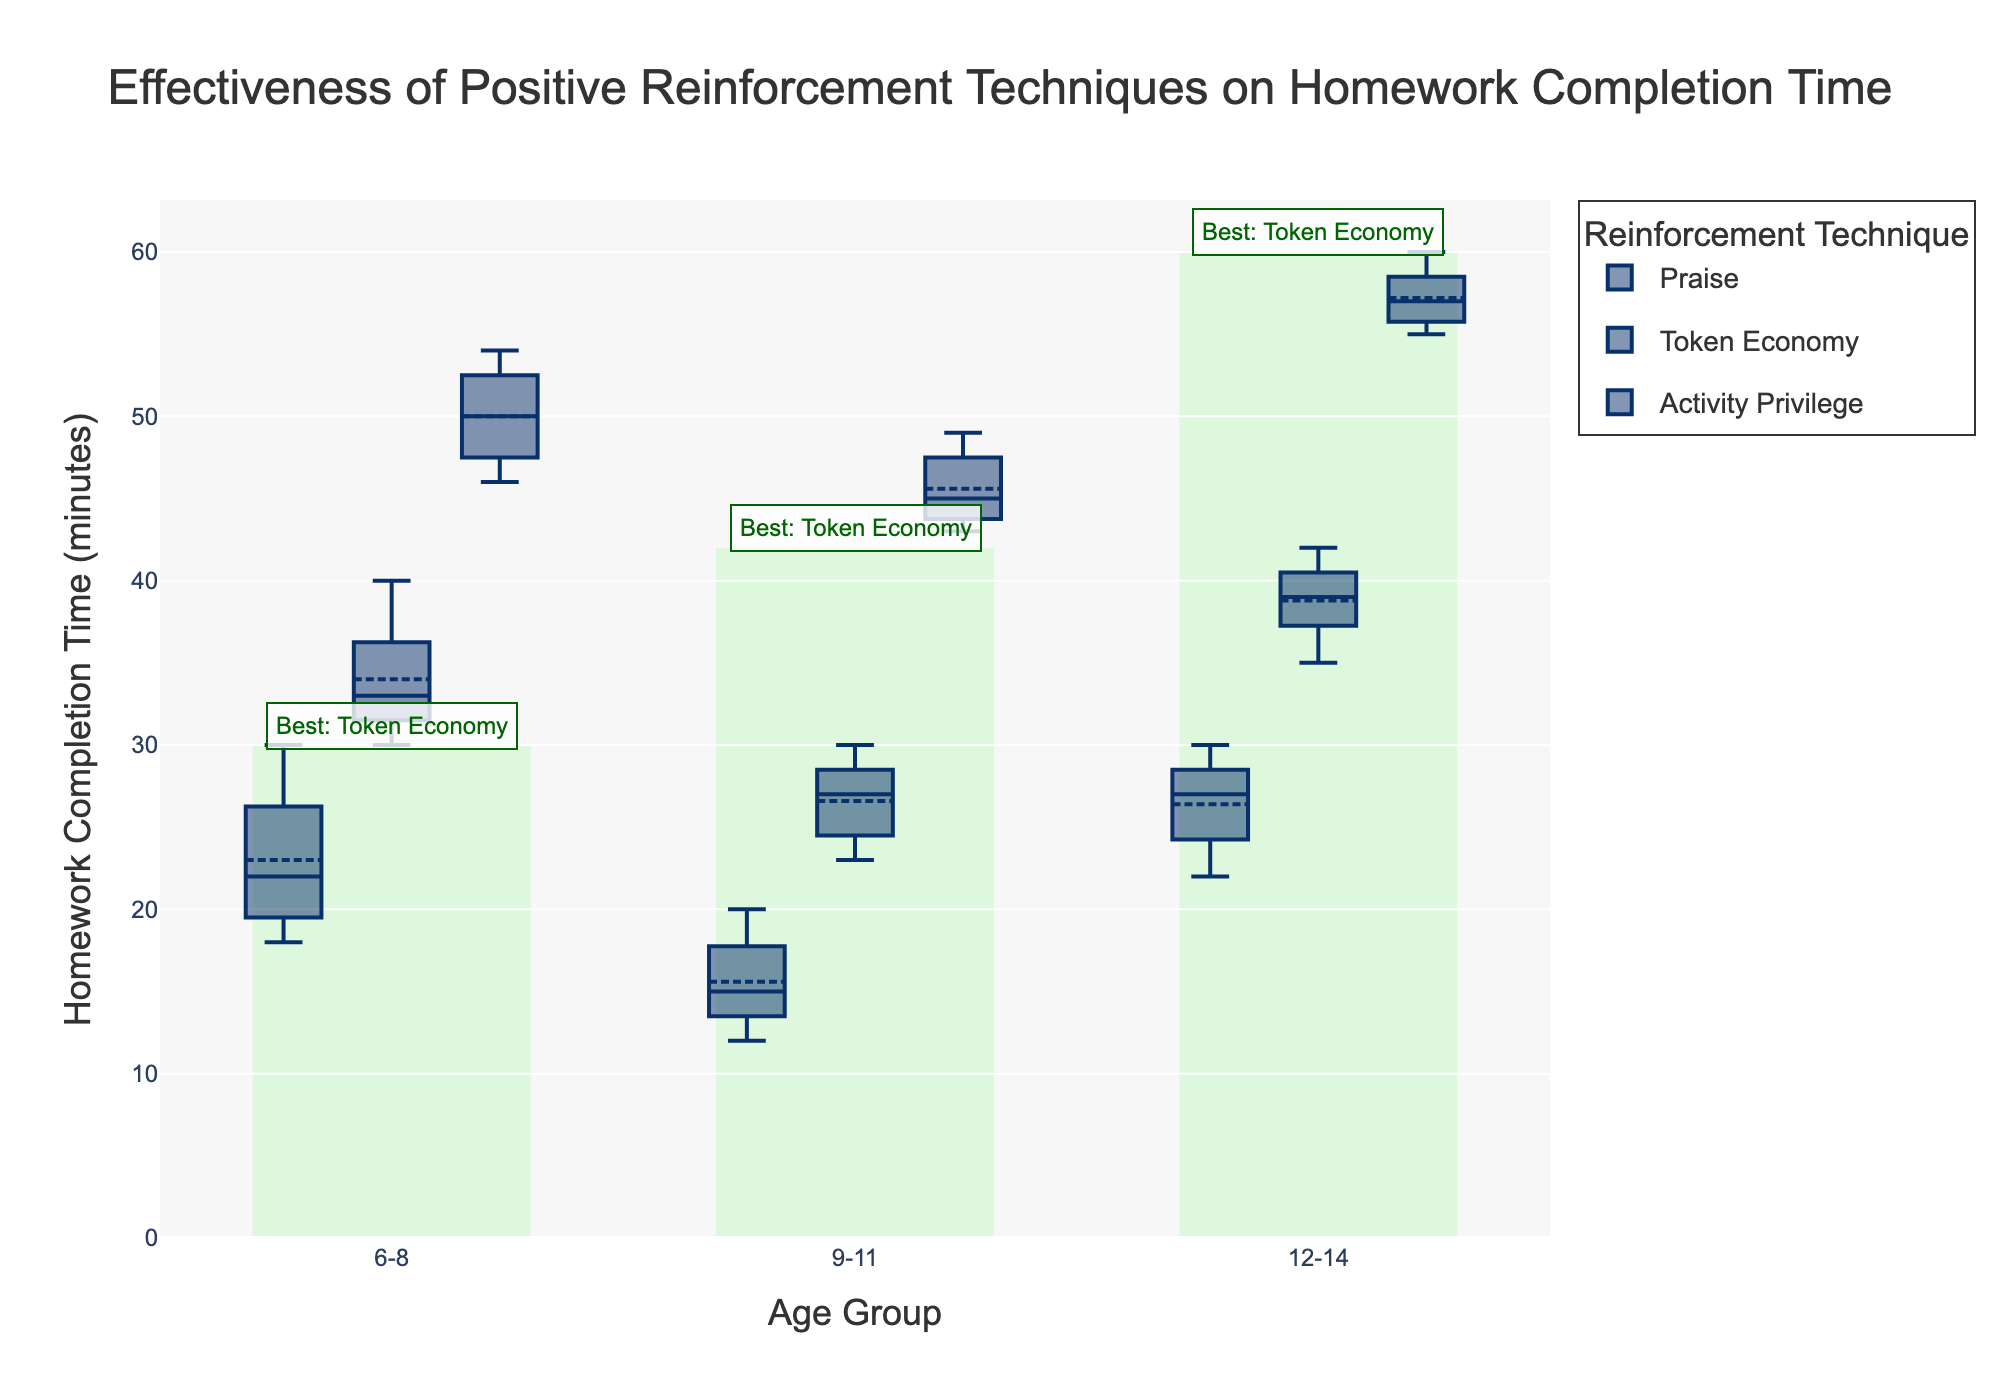What is the title of the plot? The title of the plot is found at the top center of the figure and is used to describe the overall content of the plot.
Answer: Effectiveness of Positive Reinforcement Techniques on Homework Completion Time Which age group takes the longest time to complete homework according to the plot? By looking at the y-axis which shows homework completion time and comparing across age groups, the group with the highest median value indicates the longest completion time.
Answer: 12-14 What is the shortest average homework completion time for the 6-8 age group? Identify the mean value for each reinforcement technique within the 6-8 age group and find the one with the lowest mean.
Answer: Token Economy Which reinforcement technique is indicated as the most effective for the 9-11 age group? This is highlighted in the figure with a specific annotation for the age group 9-11. Look for the annotation text indicating "Best" on the plot.
Answer: Token Economy How do the completion times compare between Praise and Token Economy for the 12-14 age group? Compare the medians of the box plots for the two techniques within the 12-14 age group. The one with a higher median indicates longer completion time.
Answer: Praise takes longer What is the median homework completion time for Activity Privilege in the 6-8 age group? For the 6-8 age group, identify the midpoint value (median) in the box plot for Activity Privilege.
Answer: 27 minutes How does the variability in homework completion time compare among the techniques for the 6-8 age group? Variability can be inferred by the range (distance between the top whisker and bottom whisker) of the box plot. Compare the ranges of the three techniques in the 6-8 age group.
Answer: Activity Privilege has the highest variability; Token Economy has the lowest Which reinforcement technique shows the highest mean completion time within the 12-14 age group? Identify the mean value shown by the horizontal line within each box plot for the 12-14 age group. The one with the highest mean line is the answer.
Answer: Activity Privilege What annotation is added to the plot, and what information does it provide? Look for any text annotations provided on the plot. Annotations typically add extra information such as the best technique for each age group.
Answer: Annotated with the best technique for each age group 